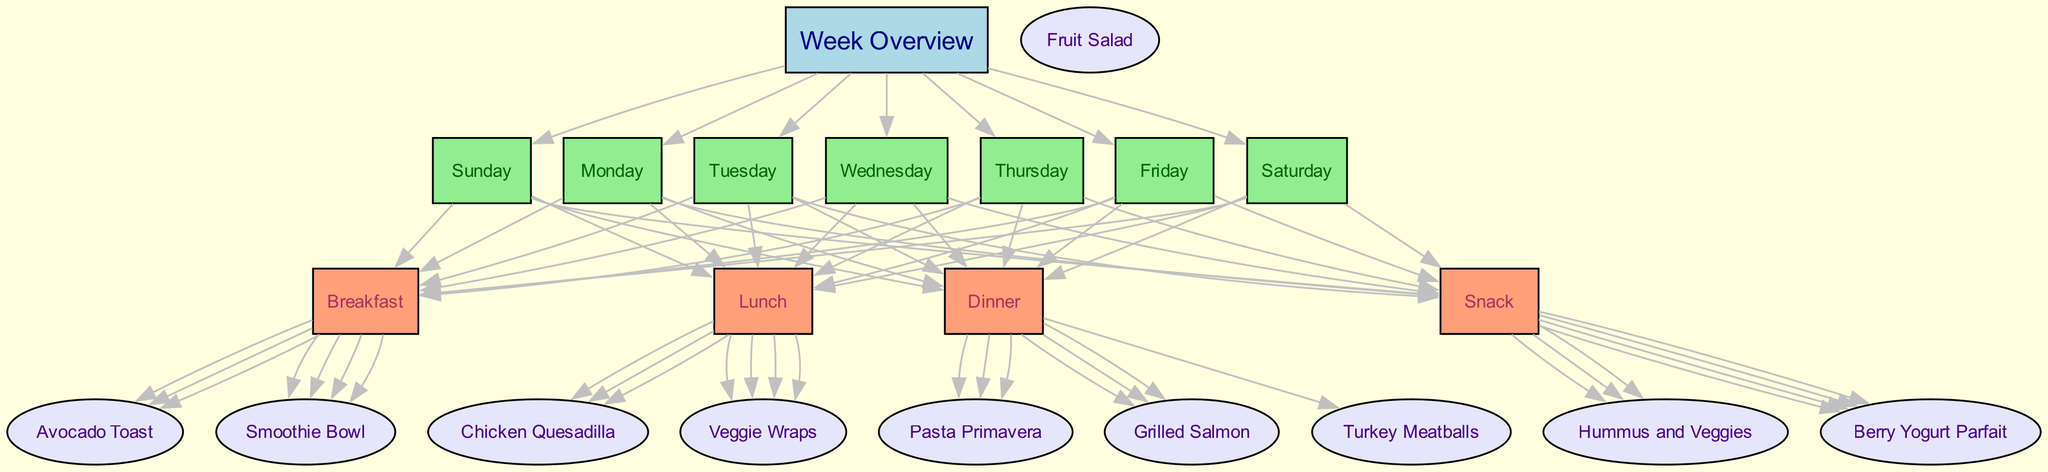What is the main title of the diagram? The title of the diagram is found at the top center of the structure, formatted as the main heading and is labeled "Weekly Family Meal Planner with Picky Eater-Friendly and Healthy Recipe Options."
Answer: Weekly Family Meal Planner with Picky Eater-Friendly and Healthy Recipe Options How many days of the week are represented in the diagram? The diagram includes nodes labeled for each day from Monday to Sunday, meaning there are seven days represented.
Answer: 7 What meal types are included in the diagram? The meal types listed in the diagram are categorized under Breakfast, Lunch, Dinner, and Snack, each represented by a separate node.
Answer: Breakfast, Lunch, Dinner, Snack On which day are Chicken Quesadillas served? To find the answer, locate the node for Tuesday and trace the edges to see the recipe options below it; Chicken Quesadillas are listed under that day.
Answer: Tuesday Which snack option is available on Monday? Follow the edge from Monday to Snack, and then check the recipe options connected to that node, where Berry Yogurt Parfait is indicated as the available snack.
Answer: Berry Yogurt Parfait What is served for dinner on Wednesday? Look at the edges coming from Wednesday's node, which leads to the Dinner category; the option for that day is Pasta Primavera.
Answer: Pasta Primavera Which breakfast option is chosen for Friday? Trace the edge from the Friday node down to the Breakfast category to see that Avocado Toast is selected for that day.
Answer: Avocado Toast Which recipe is shared on Monday and Thursday? Check the edges leading out from both Monday and Thursday; Veggie Wraps appear in the lunch category for both days, indicating they are shared.
Answer: Veggie Wraps Which meal option is associated with the largest number of recipe choices, and how many recipes are there? Review all the edges from each meal type node; the Lunch category has the most diverse recipe options connected, specifically listing Veggie Wraps and others for three days.
Answer: Lunch, 3 recipes 